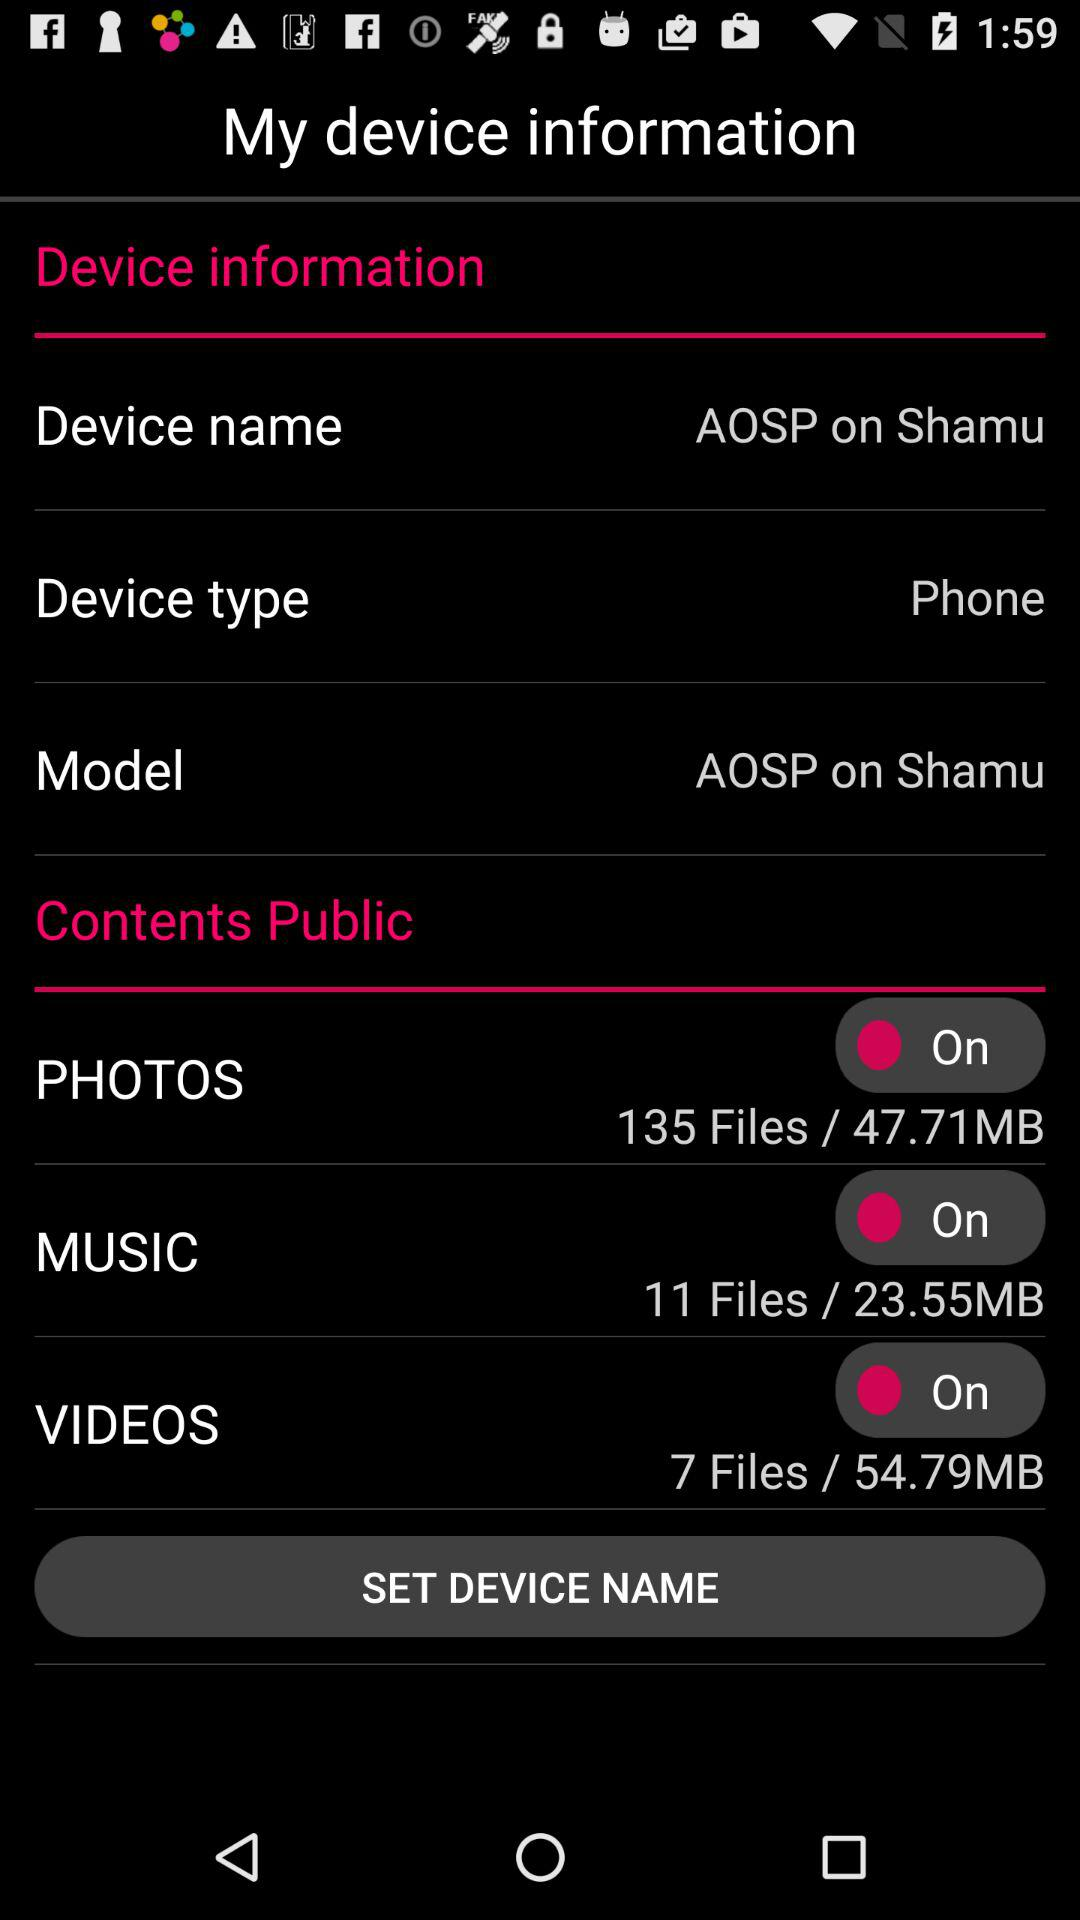How many megabytes are used by photos? There are 47.71 megabytes used by photos. 